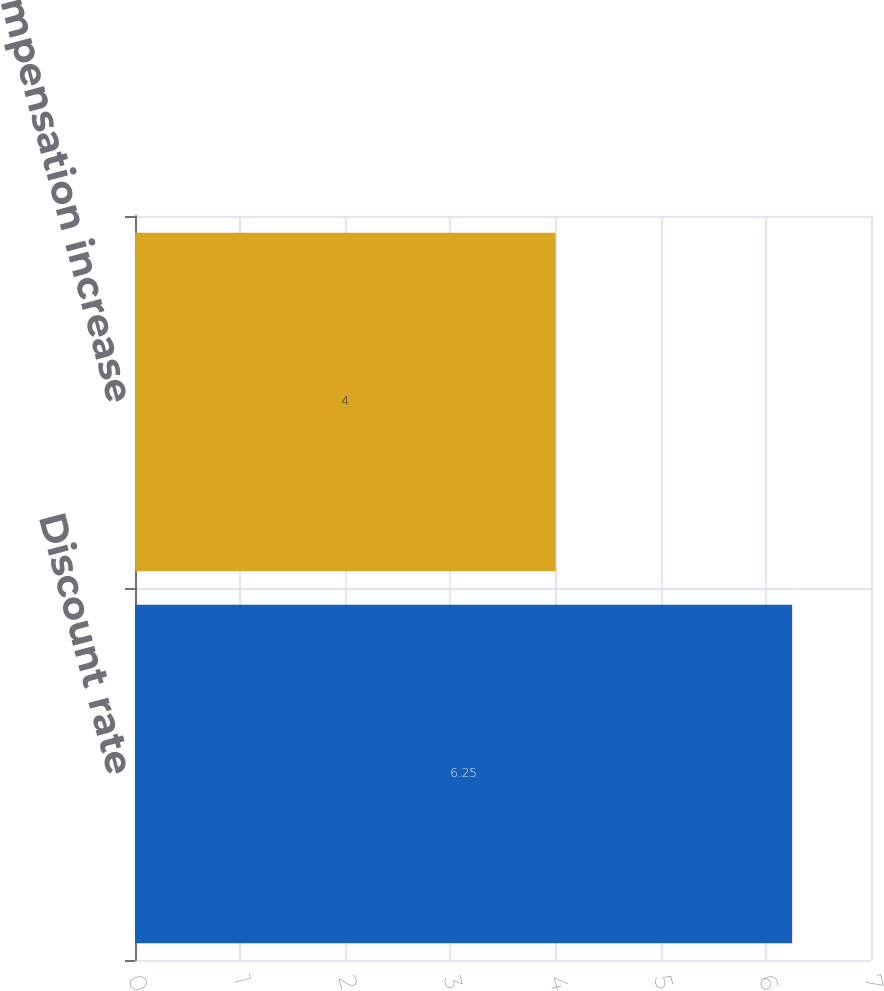Convert chart. <chart><loc_0><loc_0><loc_500><loc_500><bar_chart><fcel>Discount rate<fcel>Rate of compensation increase<nl><fcel>6.25<fcel>4<nl></chart> 